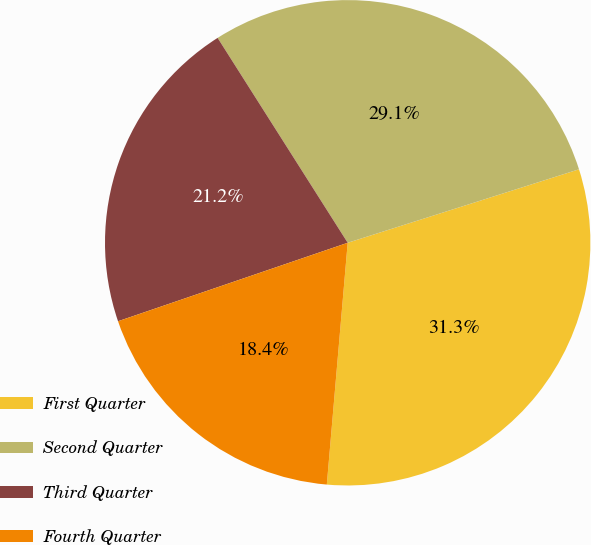Convert chart to OTSL. <chart><loc_0><loc_0><loc_500><loc_500><pie_chart><fcel>First Quarter<fcel>Second Quarter<fcel>Third Quarter<fcel>Fourth Quarter<nl><fcel>31.27%<fcel>29.11%<fcel>21.24%<fcel>18.39%<nl></chart> 